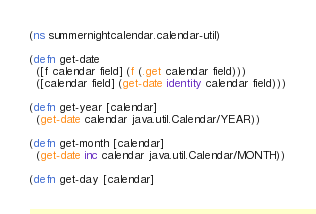Convert code to text. <code><loc_0><loc_0><loc_500><loc_500><_Clojure_>(ns summernightcalendar.calendar-util)

(defn get-date
  ([f calendar field] (f (.get calendar field)))
  ([calendar field] (get-date identity calendar field)))

(defn get-year [calendar]
  (get-date calendar java.util.Calendar/YEAR))

(defn get-month [calendar]
  (get-date inc calendar java.util.Calendar/MONTH))

(defn get-day [calendar]</code> 